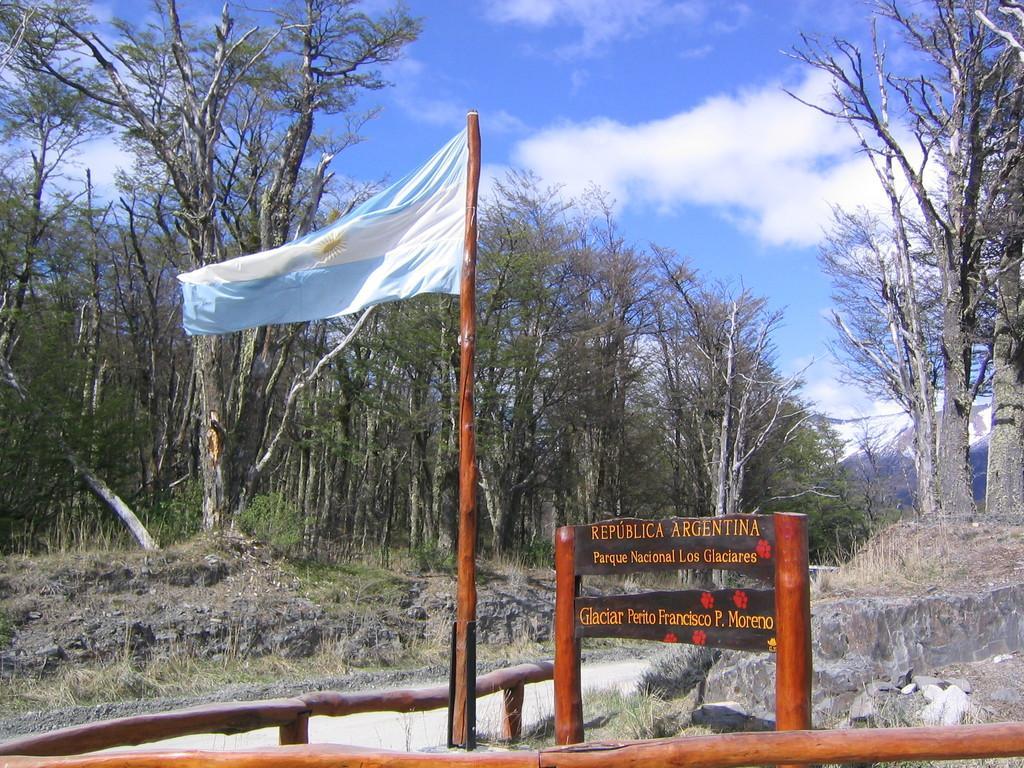Could you give a brief overview of what you see in this image? In this image we can see a flag and board with text. And there are rocks, trees, railing and the sky. 